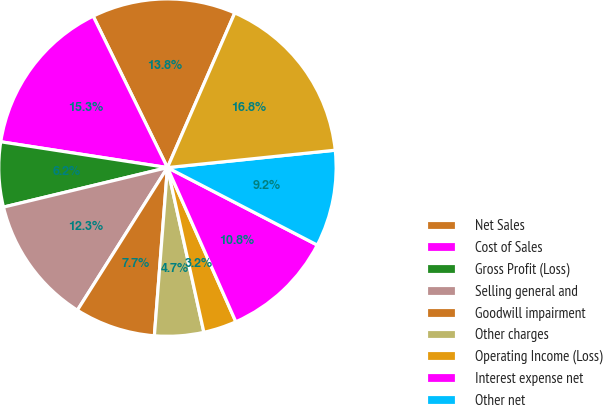<chart> <loc_0><loc_0><loc_500><loc_500><pie_chart><fcel>Net Sales<fcel>Cost of Sales<fcel>Gross Profit (Loss)<fcel>Selling general and<fcel>Goodwill impairment<fcel>Other charges<fcel>Operating Income (Loss)<fcel>Interest expense net<fcel>Other net<fcel>Equity in net earnings of<nl><fcel>13.79%<fcel>15.3%<fcel>6.21%<fcel>12.27%<fcel>7.73%<fcel>4.7%<fcel>3.18%<fcel>10.76%<fcel>9.24%<fcel>16.82%<nl></chart> 